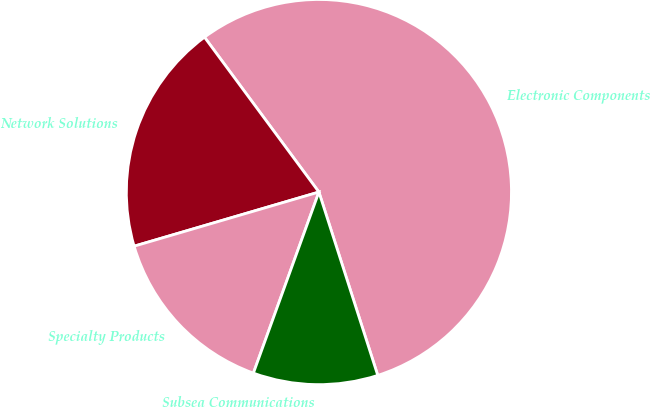<chart> <loc_0><loc_0><loc_500><loc_500><pie_chart><fcel>Electronic Components<fcel>Network Solutions<fcel>Specialty Products<fcel>Subsea Communications<nl><fcel>55.19%<fcel>19.41%<fcel>14.94%<fcel>10.47%<nl></chart> 